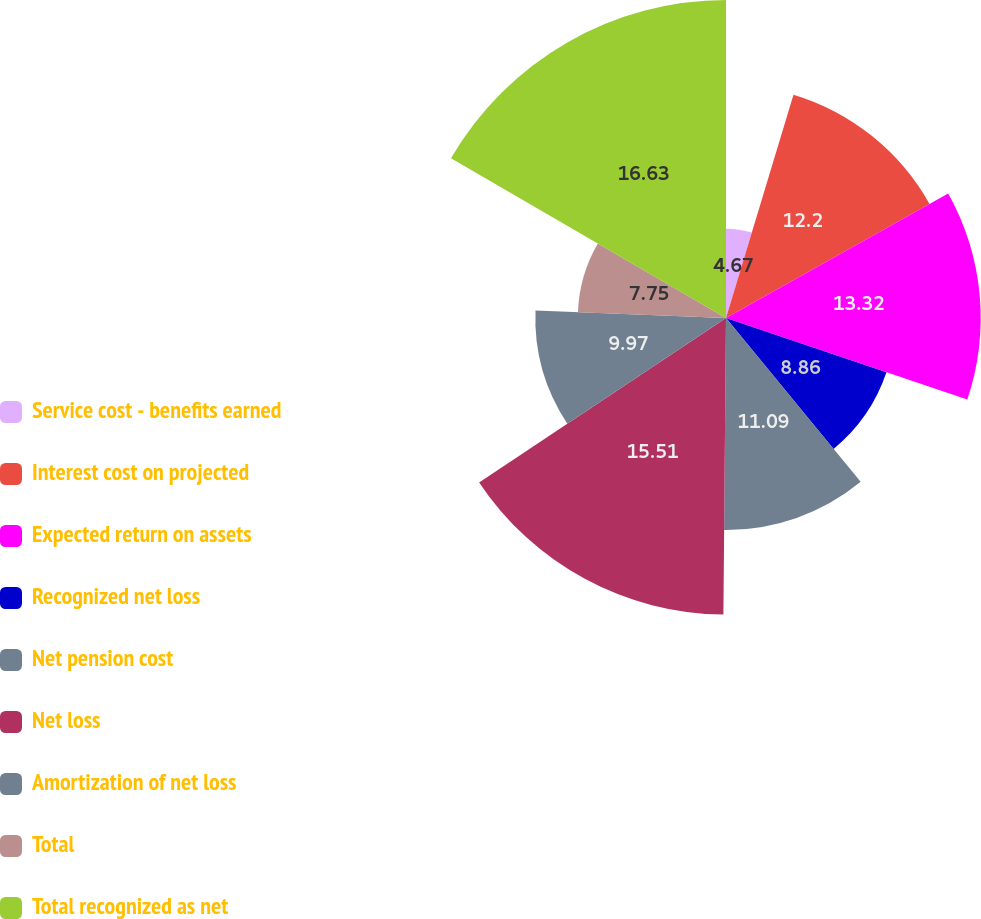<chart> <loc_0><loc_0><loc_500><loc_500><pie_chart><fcel>Service cost - benefits earned<fcel>Interest cost on projected<fcel>Expected return on assets<fcel>Recognized net loss<fcel>Net pension cost<fcel>Net loss<fcel>Amortization of net loss<fcel>Total<fcel>Total recognized as net<nl><fcel>4.67%<fcel>12.2%<fcel>13.32%<fcel>8.86%<fcel>11.09%<fcel>15.51%<fcel>9.97%<fcel>7.75%<fcel>16.63%<nl></chart> 